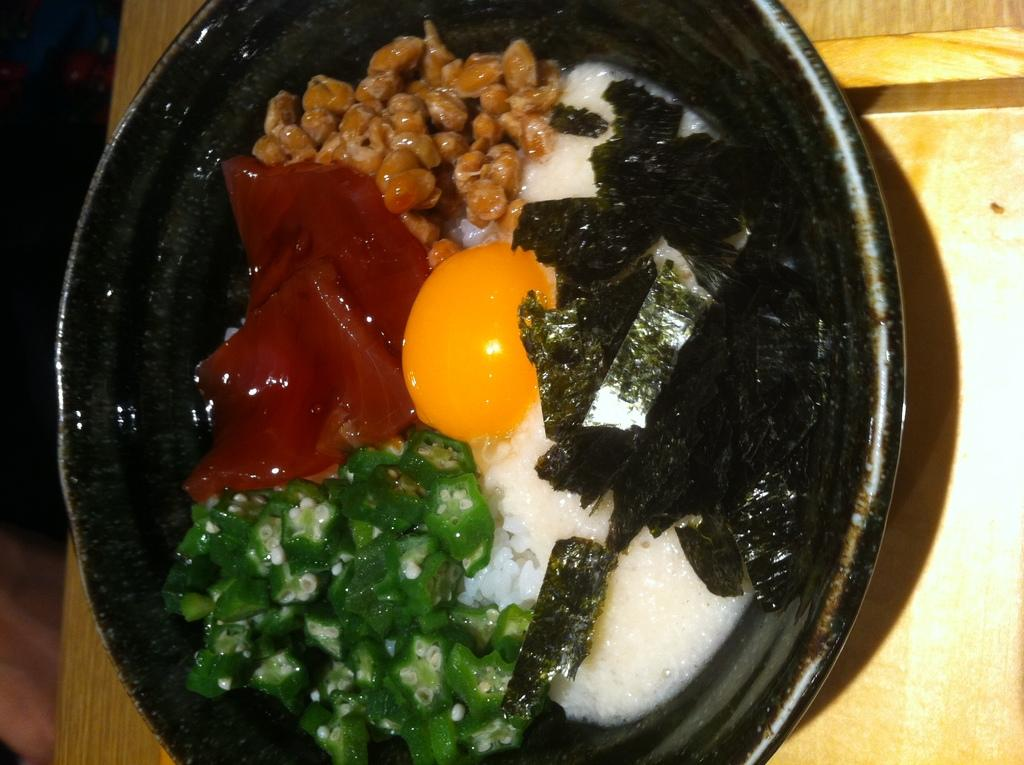What color is the bowl in the image? The bowl in the image is black. What is inside the bowl? The bowl contains food items. Where is the bowl located? The bowl is placed on a table. What type of cat is sitting on the edge of the bowl in the image? There is no cat present in the image; it only features a black color bowl containing food items placed on a table. 